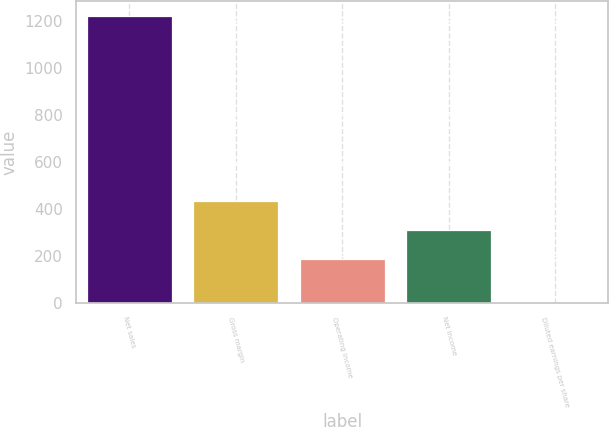Convert chart to OTSL. <chart><loc_0><loc_0><loc_500><loc_500><bar_chart><fcel>Net sales<fcel>Gross margin<fcel>Operating income<fcel>Net income<fcel>Diluted earnings per share<nl><fcel>1225<fcel>432.94<fcel>188<fcel>310.47<fcel>0.27<nl></chart> 